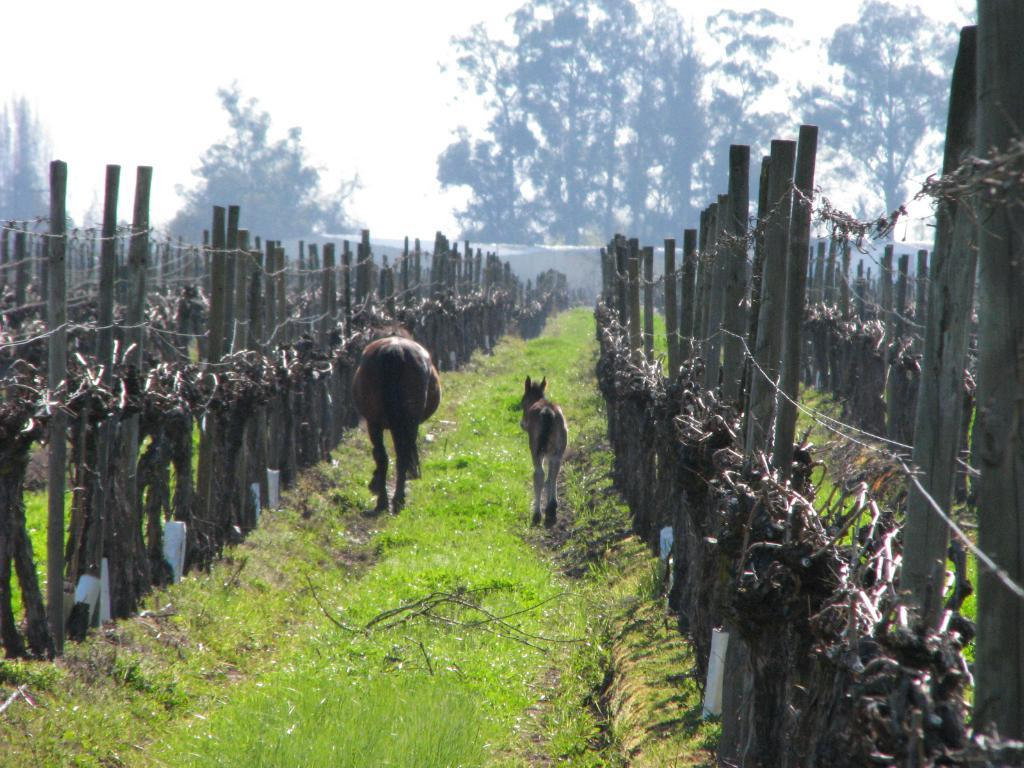What type of animals can be seen on the grassy land in the image? There are animals on the grassy land in the image. What is the purpose of the fencing on both sides of the image? The fencing on both sides of the image is likely to enclose or separate the area. What can be seen in the background of the image? There are trees and the sky visible in the background of the image. How many beggars are visible in the image? There are no beggars present in the image. Are there any spiders jumping in the image? There are no spiders or jumping depicted in the image. 